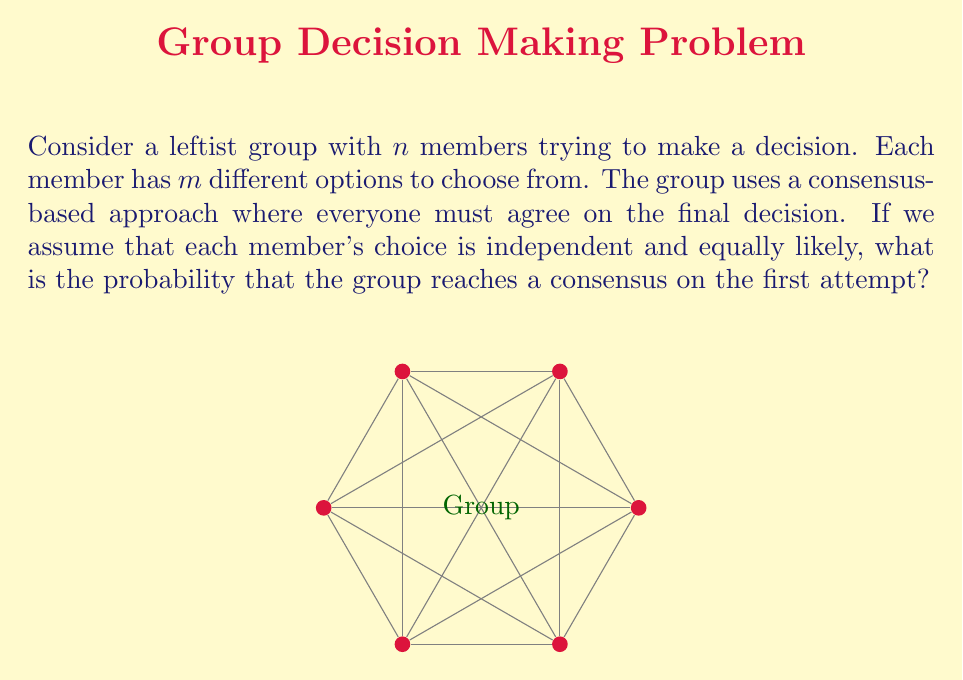Could you help me with this problem? Let's approach this step-by-step:

1) For the group to reach a consensus on the first attempt, all $n$ members must independently choose the same option out of $m$ possibilities.

2) The probability of any single member choosing a specific option is $\frac{1}{m}$, as all options are equally likely.

3) For all $n$ members to choose the same option, we need this to happen $n$ times independently. In probability theory, when we want independent events to all occur, we multiply their individual probabilities.

4) Therefore, the probability of all members choosing the same option is:

   $$P(\text{consensus}) = \left(\frac{1}{m}\right)^n$$

5) This formula gives us the probability for a specific option being chosen by everyone. However, consensus could be reached on any of the $m$ options.

6) Since these outcomes are mutually exclusive (the group can't reach consensus on more than one option simultaneously), we add the probabilities for each possible consensus:

   $$P(\text{any consensus}) = m \cdot \left(\frac{1}{m}\right)^n = \frac{m}{m^n} = \frac{1}{m^{n-1}}$$

This final expression gives us the probability of the group reaching a consensus on the first attempt, highlighting how quickly the likelihood of immediate agreement decreases as the group size or number of options increases - a reflection of the complexity in group decision-making processes.
Answer: $\frac{1}{m^{n-1}}$ 